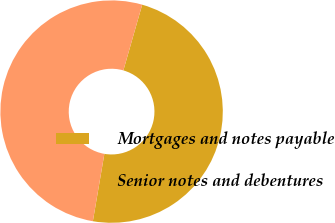Convert chart to OTSL. <chart><loc_0><loc_0><loc_500><loc_500><pie_chart><fcel>Mortgages and notes payable<fcel>Senior notes and debentures<nl><fcel>48.26%<fcel>51.74%<nl></chart> 